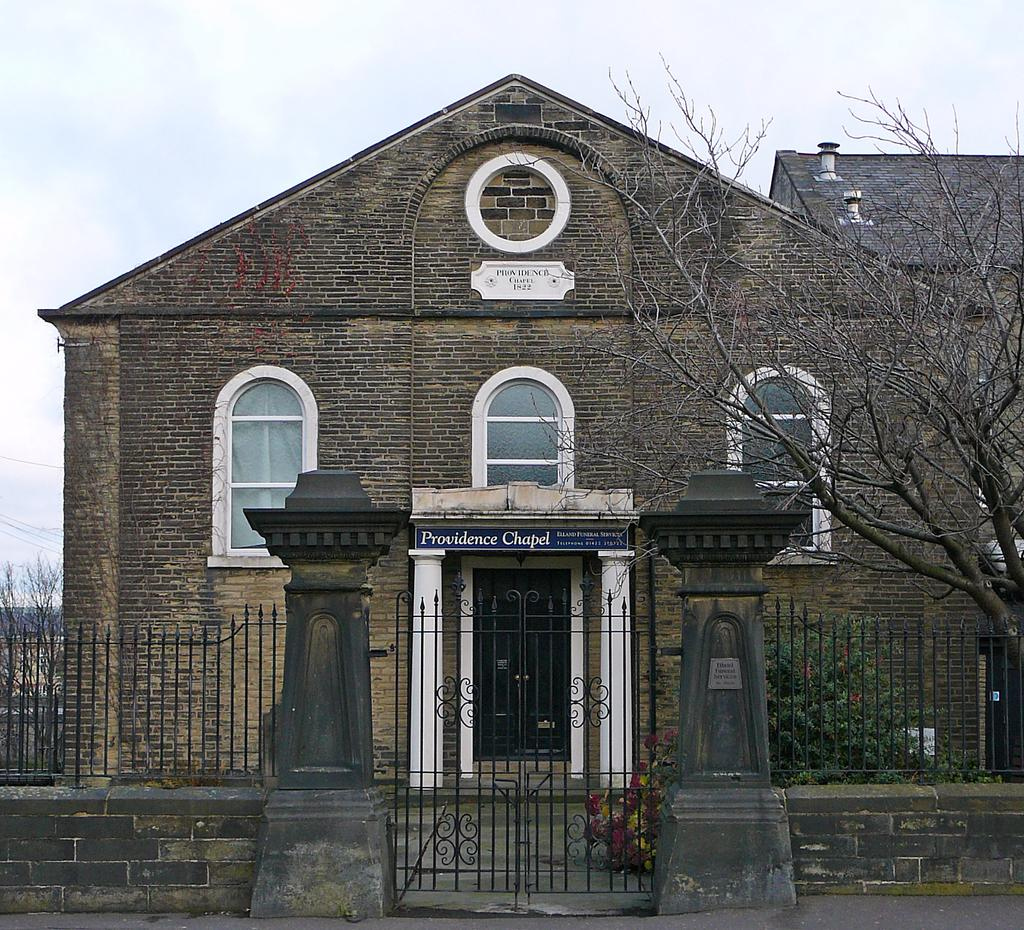What type of structure can be seen in the image? There is a gate, fences, a building, and name boards on the wall in the image. What architectural features are present on the building? There are windows and doors on the building in the image. What type of vegetation is visible in the image? There are bare trees in the image. What can be seen in the sky? Clouds are visible in the sky. Where is the sink located in the image? There is no sink present in the image. Can you see a fireman in the image? There is no fireman present in the image. 